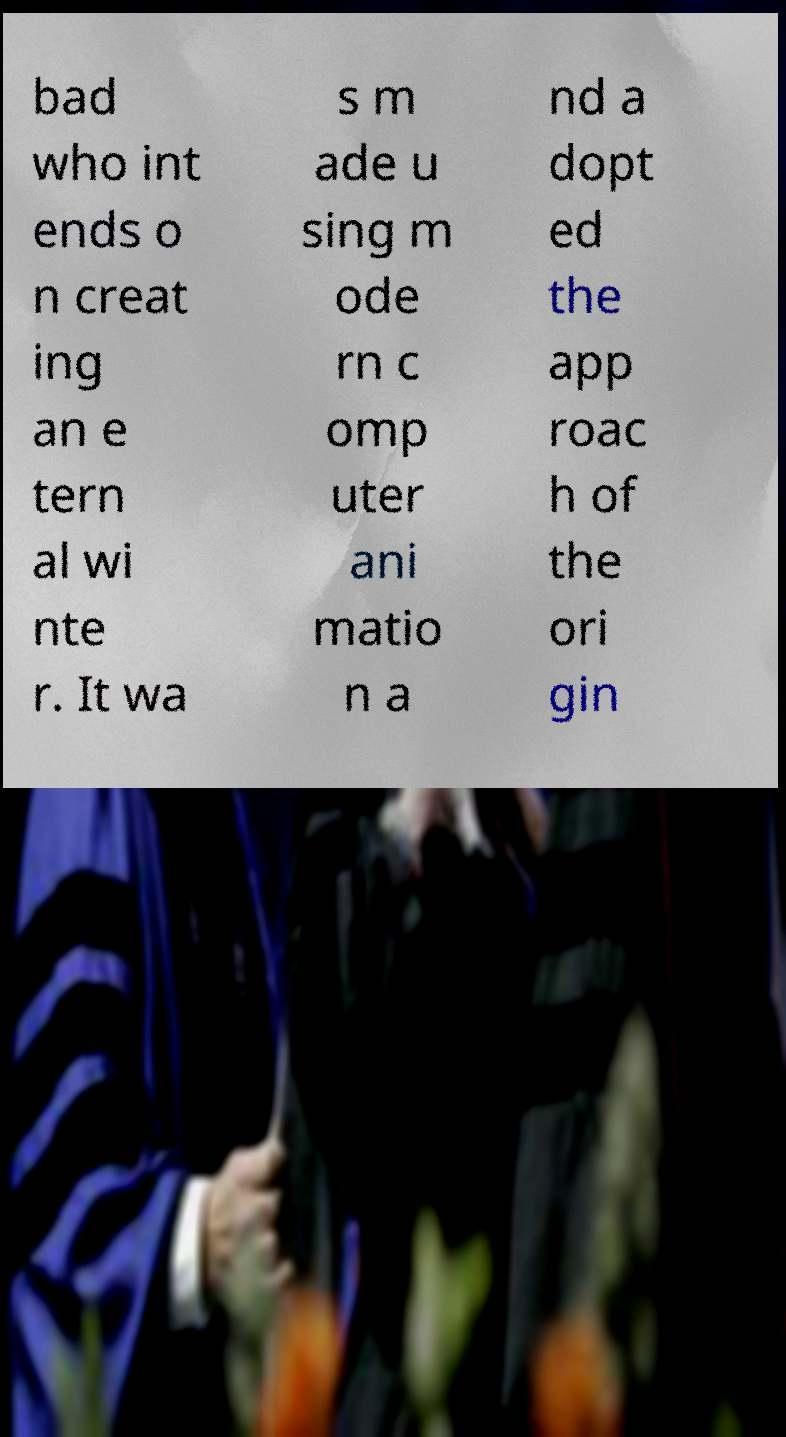For documentation purposes, I need the text within this image transcribed. Could you provide that? bad who int ends o n creat ing an e tern al wi nte r. It wa s m ade u sing m ode rn c omp uter ani matio n a nd a dopt ed the app roac h of the ori gin 